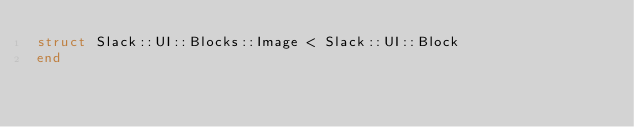<code> <loc_0><loc_0><loc_500><loc_500><_Crystal_>struct Slack::UI::Blocks::Image < Slack::UI::Block
end
</code> 